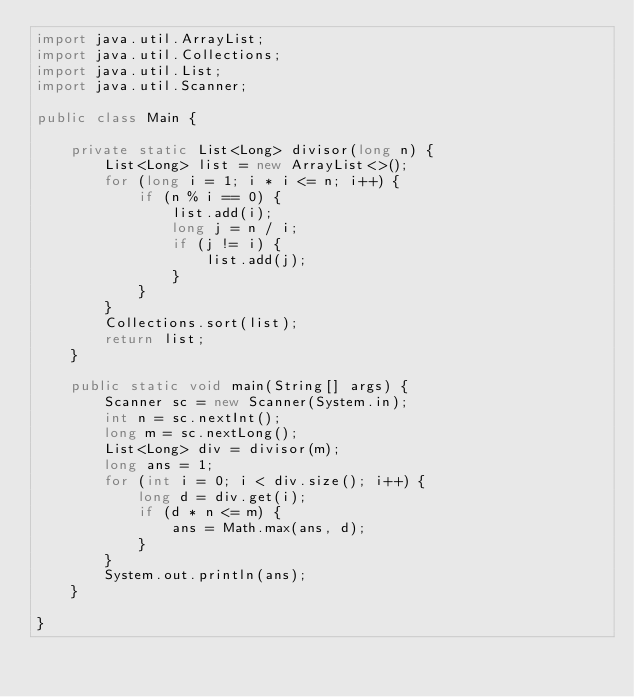<code> <loc_0><loc_0><loc_500><loc_500><_Java_>import java.util.ArrayList;
import java.util.Collections;
import java.util.List;
import java.util.Scanner;
 
public class Main {
 
    private static List<Long> divisor(long n) {
        List<Long> list = new ArrayList<>();
        for (long i = 1; i * i <= n; i++) {
            if (n % i == 0) {
                list.add(i);
                long j = n / i;
                if (j != i) {
                    list.add(j);
                }
            }
        }
        Collections.sort(list);
        return list;
    }
 
    public static void main(String[] args) {
        Scanner sc = new Scanner(System.in);
        int n = sc.nextInt();
        long m = sc.nextLong();
        List<Long> div = divisor(m);
        long ans = 1;
        for (int i = 0; i < div.size(); i++) {
            long d = div.get(i);
            if (d * n <= m) {
                ans = Math.max(ans, d);
            }
        }
        System.out.println(ans);
    }
 
}</code> 